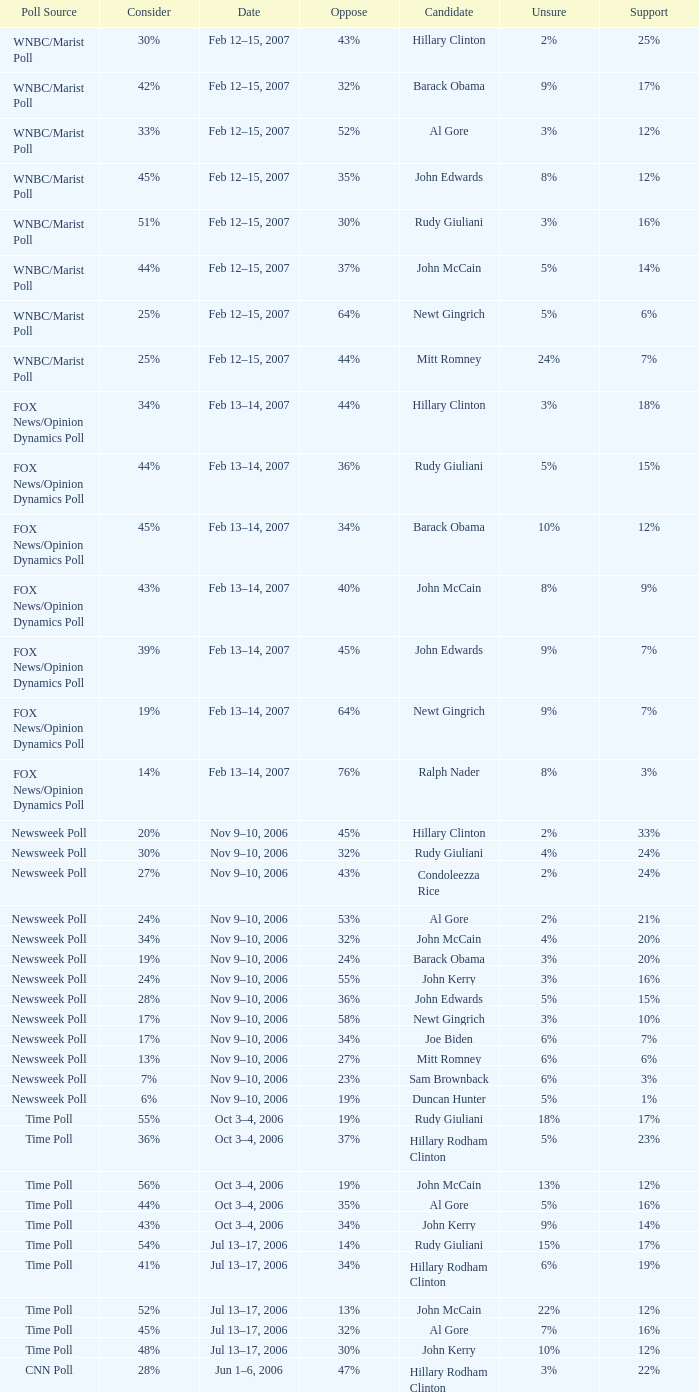What percentage of people said they would consider Rudy Giuliani as a candidate according to the Newsweek poll that showed 32% opposed him? 30%. 